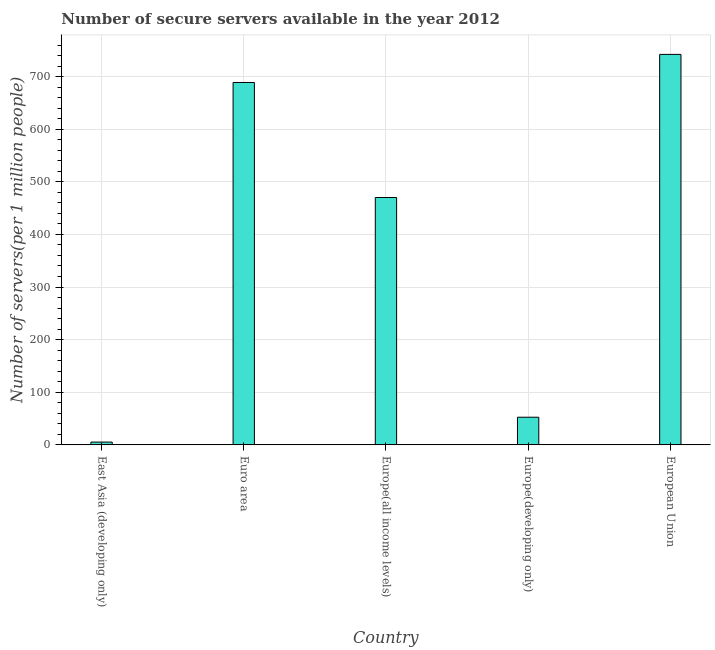Does the graph contain grids?
Keep it short and to the point. Yes. What is the title of the graph?
Provide a short and direct response. Number of secure servers available in the year 2012. What is the label or title of the X-axis?
Your response must be concise. Country. What is the label or title of the Y-axis?
Keep it short and to the point. Number of servers(per 1 million people). What is the number of secure internet servers in Europe(all income levels)?
Make the answer very short. 470.22. Across all countries, what is the maximum number of secure internet servers?
Your answer should be very brief. 742.35. Across all countries, what is the minimum number of secure internet servers?
Provide a succinct answer. 5.15. In which country was the number of secure internet servers minimum?
Give a very brief answer. East Asia (developing only). What is the sum of the number of secure internet servers?
Your answer should be very brief. 1959.1. What is the difference between the number of secure internet servers in Euro area and Europe(all income levels)?
Keep it short and to the point. 218.73. What is the average number of secure internet servers per country?
Provide a short and direct response. 391.82. What is the median number of secure internet servers?
Provide a short and direct response. 470.22. What is the ratio of the number of secure internet servers in East Asia (developing only) to that in Europe(developing only)?
Make the answer very short. 0.1. Is the number of secure internet servers in Europe(all income levels) less than that in Europe(developing only)?
Offer a very short reply. No. What is the difference between the highest and the second highest number of secure internet servers?
Ensure brevity in your answer.  53.39. Is the sum of the number of secure internet servers in Euro area and Europe(developing only) greater than the maximum number of secure internet servers across all countries?
Your answer should be very brief. No. What is the difference between the highest and the lowest number of secure internet servers?
Keep it short and to the point. 737.2. Are all the bars in the graph horizontal?
Your answer should be compact. No. What is the difference between two consecutive major ticks on the Y-axis?
Your answer should be compact. 100. Are the values on the major ticks of Y-axis written in scientific E-notation?
Provide a short and direct response. No. What is the Number of servers(per 1 million people) in East Asia (developing only)?
Provide a succinct answer. 5.15. What is the Number of servers(per 1 million people) of Euro area?
Provide a short and direct response. 688.96. What is the Number of servers(per 1 million people) in Europe(all income levels)?
Provide a succinct answer. 470.22. What is the Number of servers(per 1 million people) of Europe(developing only)?
Make the answer very short. 52.42. What is the Number of servers(per 1 million people) in European Union?
Offer a very short reply. 742.35. What is the difference between the Number of servers(per 1 million people) in East Asia (developing only) and Euro area?
Your answer should be very brief. -683.81. What is the difference between the Number of servers(per 1 million people) in East Asia (developing only) and Europe(all income levels)?
Your answer should be very brief. -465.07. What is the difference between the Number of servers(per 1 million people) in East Asia (developing only) and Europe(developing only)?
Offer a very short reply. -47.27. What is the difference between the Number of servers(per 1 million people) in East Asia (developing only) and European Union?
Offer a very short reply. -737.2. What is the difference between the Number of servers(per 1 million people) in Euro area and Europe(all income levels)?
Your response must be concise. 218.73. What is the difference between the Number of servers(per 1 million people) in Euro area and Europe(developing only)?
Offer a very short reply. 636.54. What is the difference between the Number of servers(per 1 million people) in Euro area and European Union?
Provide a succinct answer. -53.39. What is the difference between the Number of servers(per 1 million people) in Europe(all income levels) and Europe(developing only)?
Provide a short and direct response. 417.8. What is the difference between the Number of servers(per 1 million people) in Europe(all income levels) and European Union?
Keep it short and to the point. -272.12. What is the difference between the Number of servers(per 1 million people) in Europe(developing only) and European Union?
Keep it short and to the point. -689.93. What is the ratio of the Number of servers(per 1 million people) in East Asia (developing only) to that in Euro area?
Give a very brief answer. 0.01. What is the ratio of the Number of servers(per 1 million people) in East Asia (developing only) to that in Europe(all income levels)?
Give a very brief answer. 0.01. What is the ratio of the Number of servers(per 1 million people) in East Asia (developing only) to that in Europe(developing only)?
Provide a short and direct response. 0.1. What is the ratio of the Number of servers(per 1 million people) in East Asia (developing only) to that in European Union?
Your response must be concise. 0.01. What is the ratio of the Number of servers(per 1 million people) in Euro area to that in Europe(all income levels)?
Your answer should be very brief. 1.47. What is the ratio of the Number of servers(per 1 million people) in Euro area to that in Europe(developing only)?
Your answer should be compact. 13.14. What is the ratio of the Number of servers(per 1 million people) in Euro area to that in European Union?
Offer a very short reply. 0.93. What is the ratio of the Number of servers(per 1 million people) in Europe(all income levels) to that in Europe(developing only)?
Keep it short and to the point. 8.97. What is the ratio of the Number of servers(per 1 million people) in Europe(all income levels) to that in European Union?
Provide a short and direct response. 0.63. What is the ratio of the Number of servers(per 1 million people) in Europe(developing only) to that in European Union?
Provide a succinct answer. 0.07. 